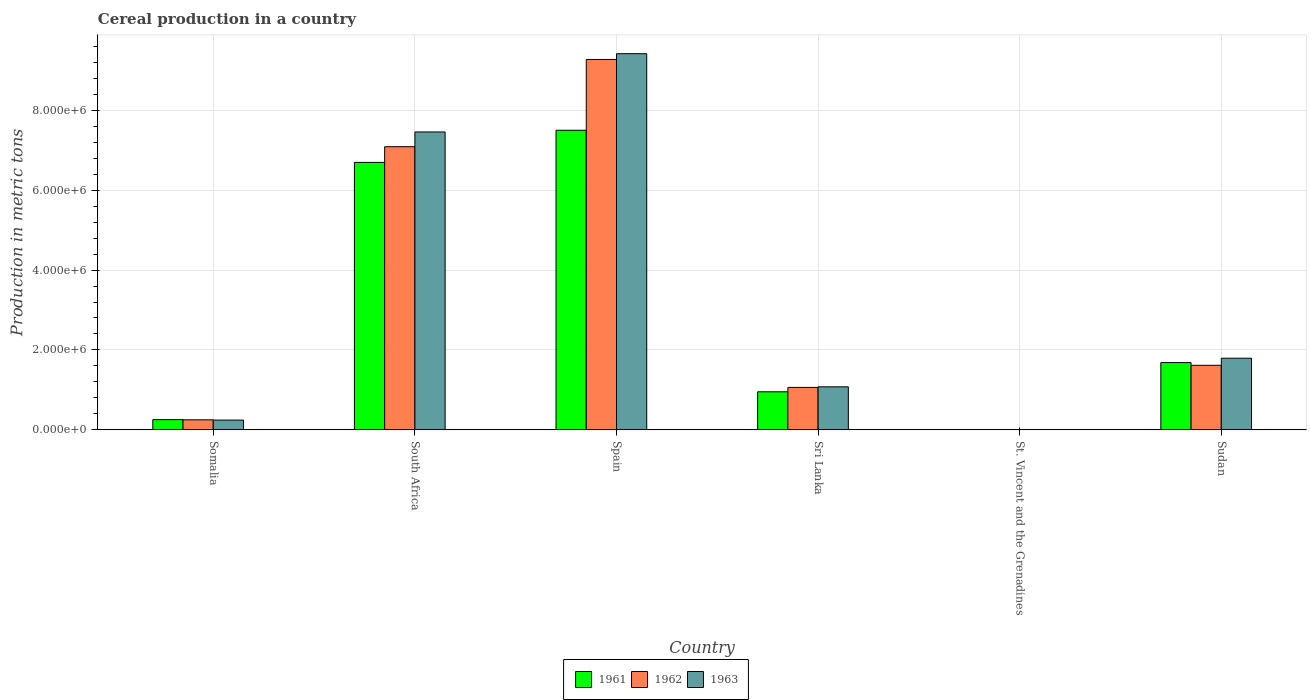How many different coloured bars are there?
Your answer should be very brief. 3. How many groups of bars are there?
Make the answer very short. 6. Are the number of bars per tick equal to the number of legend labels?
Provide a succinct answer. Yes. How many bars are there on the 1st tick from the left?
Your answer should be very brief. 3. What is the label of the 6th group of bars from the left?
Provide a short and direct response. Sudan. In how many cases, is the number of bars for a given country not equal to the number of legend labels?
Offer a terse response. 0. What is the total cereal production in 1961 in Spain?
Provide a short and direct response. 7.50e+06. Across all countries, what is the maximum total cereal production in 1963?
Provide a succinct answer. 9.42e+06. Across all countries, what is the minimum total cereal production in 1961?
Provide a short and direct response. 400. In which country was the total cereal production in 1963 minimum?
Offer a terse response. St. Vincent and the Grenadines. What is the total total cereal production in 1963 in the graph?
Give a very brief answer. 2.00e+07. What is the difference between the total cereal production in 1962 in Somalia and that in Spain?
Ensure brevity in your answer.  -9.02e+06. What is the difference between the total cereal production in 1961 in St. Vincent and the Grenadines and the total cereal production in 1963 in Sudan?
Keep it short and to the point. -1.79e+06. What is the average total cereal production in 1962 per country?
Make the answer very short. 3.22e+06. What is the difference between the total cereal production of/in 1961 and total cereal production of/in 1963 in Somalia?
Ensure brevity in your answer.  1.20e+04. What is the ratio of the total cereal production in 1963 in South Africa to that in Sudan?
Offer a terse response. 4.16. What is the difference between the highest and the second highest total cereal production in 1961?
Your response must be concise. 5.82e+06. What is the difference between the highest and the lowest total cereal production in 1961?
Give a very brief answer. 7.50e+06. In how many countries, is the total cereal production in 1961 greater than the average total cereal production in 1961 taken over all countries?
Offer a terse response. 2. What does the 1st bar from the left in St. Vincent and the Grenadines represents?
Offer a terse response. 1961. Is it the case that in every country, the sum of the total cereal production in 1962 and total cereal production in 1961 is greater than the total cereal production in 1963?
Offer a very short reply. Yes. Are the values on the major ticks of Y-axis written in scientific E-notation?
Your answer should be compact. Yes. Where does the legend appear in the graph?
Give a very brief answer. Bottom center. How many legend labels are there?
Provide a succinct answer. 3. What is the title of the graph?
Offer a very short reply. Cereal production in a country. Does "2002" appear as one of the legend labels in the graph?
Keep it short and to the point. No. What is the label or title of the X-axis?
Provide a succinct answer. Country. What is the label or title of the Y-axis?
Provide a succinct answer. Production in metric tons. What is the Production in metric tons in 1961 in Somalia?
Your response must be concise. 2.55e+05. What is the Production in metric tons of 1963 in Somalia?
Your response must be concise. 2.43e+05. What is the Production in metric tons in 1961 in South Africa?
Provide a succinct answer. 6.70e+06. What is the Production in metric tons of 1962 in South Africa?
Offer a very short reply. 7.09e+06. What is the Production in metric tons in 1963 in South Africa?
Give a very brief answer. 7.46e+06. What is the Production in metric tons of 1961 in Spain?
Provide a succinct answer. 7.50e+06. What is the Production in metric tons of 1962 in Spain?
Offer a terse response. 9.27e+06. What is the Production in metric tons in 1963 in Spain?
Your answer should be compact. 9.42e+06. What is the Production in metric tons in 1961 in Sri Lanka?
Keep it short and to the point. 9.52e+05. What is the Production in metric tons in 1962 in Sri Lanka?
Your answer should be compact. 1.06e+06. What is the Production in metric tons in 1963 in Sri Lanka?
Provide a short and direct response. 1.08e+06. What is the Production in metric tons of 1961 in Sudan?
Your answer should be compact. 1.68e+06. What is the Production in metric tons of 1962 in Sudan?
Your response must be concise. 1.62e+06. What is the Production in metric tons of 1963 in Sudan?
Provide a succinct answer. 1.79e+06. Across all countries, what is the maximum Production in metric tons in 1961?
Provide a short and direct response. 7.50e+06. Across all countries, what is the maximum Production in metric tons in 1962?
Your response must be concise. 9.27e+06. Across all countries, what is the maximum Production in metric tons in 1963?
Your answer should be very brief. 9.42e+06. Across all countries, what is the minimum Production in metric tons of 1962?
Offer a terse response. 400. What is the total Production in metric tons in 1961 in the graph?
Keep it short and to the point. 1.71e+07. What is the total Production in metric tons of 1962 in the graph?
Keep it short and to the point. 1.93e+07. What is the total Production in metric tons of 1963 in the graph?
Keep it short and to the point. 2.00e+07. What is the difference between the Production in metric tons in 1961 in Somalia and that in South Africa?
Your response must be concise. -6.44e+06. What is the difference between the Production in metric tons of 1962 in Somalia and that in South Africa?
Make the answer very short. -6.84e+06. What is the difference between the Production in metric tons in 1963 in Somalia and that in South Africa?
Make the answer very short. -7.22e+06. What is the difference between the Production in metric tons in 1961 in Somalia and that in Spain?
Your answer should be very brief. -7.25e+06. What is the difference between the Production in metric tons of 1962 in Somalia and that in Spain?
Your response must be concise. -9.02e+06. What is the difference between the Production in metric tons in 1963 in Somalia and that in Spain?
Provide a succinct answer. -9.18e+06. What is the difference between the Production in metric tons of 1961 in Somalia and that in Sri Lanka?
Make the answer very short. -6.97e+05. What is the difference between the Production in metric tons in 1962 in Somalia and that in Sri Lanka?
Give a very brief answer. -8.12e+05. What is the difference between the Production in metric tons of 1963 in Somalia and that in Sri Lanka?
Provide a short and direct response. -8.34e+05. What is the difference between the Production in metric tons of 1961 in Somalia and that in St. Vincent and the Grenadines?
Your answer should be compact. 2.55e+05. What is the difference between the Production in metric tons of 1962 in Somalia and that in St. Vincent and the Grenadines?
Give a very brief answer. 2.50e+05. What is the difference between the Production in metric tons in 1963 in Somalia and that in St. Vincent and the Grenadines?
Ensure brevity in your answer.  2.43e+05. What is the difference between the Production in metric tons of 1961 in Somalia and that in Sudan?
Offer a terse response. -1.43e+06. What is the difference between the Production in metric tons in 1962 in Somalia and that in Sudan?
Give a very brief answer. -1.37e+06. What is the difference between the Production in metric tons of 1963 in Somalia and that in Sudan?
Provide a succinct answer. -1.55e+06. What is the difference between the Production in metric tons in 1961 in South Africa and that in Spain?
Your response must be concise. -8.05e+05. What is the difference between the Production in metric tons of 1962 in South Africa and that in Spain?
Keep it short and to the point. -2.19e+06. What is the difference between the Production in metric tons of 1963 in South Africa and that in Spain?
Provide a short and direct response. -1.96e+06. What is the difference between the Production in metric tons in 1961 in South Africa and that in Sri Lanka?
Your answer should be very brief. 5.74e+06. What is the difference between the Production in metric tons in 1962 in South Africa and that in Sri Lanka?
Offer a very short reply. 6.03e+06. What is the difference between the Production in metric tons of 1963 in South Africa and that in Sri Lanka?
Your response must be concise. 6.38e+06. What is the difference between the Production in metric tons of 1961 in South Africa and that in St. Vincent and the Grenadines?
Offer a very short reply. 6.70e+06. What is the difference between the Production in metric tons of 1962 in South Africa and that in St. Vincent and the Grenadines?
Offer a terse response. 7.09e+06. What is the difference between the Production in metric tons of 1963 in South Africa and that in St. Vincent and the Grenadines?
Provide a short and direct response. 7.46e+06. What is the difference between the Production in metric tons in 1961 in South Africa and that in Sudan?
Ensure brevity in your answer.  5.01e+06. What is the difference between the Production in metric tons of 1962 in South Africa and that in Sudan?
Provide a succinct answer. 5.47e+06. What is the difference between the Production in metric tons of 1963 in South Africa and that in Sudan?
Provide a succinct answer. 5.67e+06. What is the difference between the Production in metric tons in 1961 in Spain and that in Sri Lanka?
Your answer should be very brief. 6.55e+06. What is the difference between the Production in metric tons in 1962 in Spain and that in Sri Lanka?
Make the answer very short. 8.21e+06. What is the difference between the Production in metric tons of 1963 in Spain and that in Sri Lanka?
Offer a terse response. 8.34e+06. What is the difference between the Production in metric tons in 1961 in Spain and that in St. Vincent and the Grenadines?
Give a very brief answer. 7.50e+06. What is the difference between the Production in metric tons in 1962 in Spain and that in St. Vincent and the Grenadines?
Ensure brevity in your answer.  9.27e+06. What is the difference between the Production in metric tons of 1963 in Spain and that in St. Vincent and the Grenadines?
Ensure brevity in your answer.  9.42e+06. What is the difference between the Production in metric tons of 1961 in Spain and that in Sudan?
Give a very brief answer. 5.82e+06. What is the difference between the Production in metric tons in 1962 in Spain and that in Sudan?
Your answer should be compact. 7.66e+06. What is the difference between the Production in metric tons of 1963 in Spain and that in Sudan?
Your answer should be very brief. 7.63e+06. What is the difference between the Production in metric tons of 1961 in Sri Lanka and that in St. Vincent and the Grenadines?
Your answer should be very brief. 9.51e+05. What is the difference between the Production in metric tons of 1962 in Sri Lanka and that in St. Vincent and the Grenadines?
Ensure brevity in your answer.  1.06e+06. What is the difference between the Production in metric tons of 1963 in Sri Lanka and that in St. Vincent and the Grenadines?
Provide a short and direct response. 1.08e+06. What is the difference between the Production in metric tons of 1961 in Sri Lanka and that in Sudan?
Provide a succinct answer. -7.31e+05. What is the difference between the Production in metric tons of 1962 in Sri Lanka and that in Sudan?
Ensure brevity in your answer.  -5.54e+05. What is the difference between the Production in metric tons of 1963 in Sri Lanka and that in Sudan?
Your answer should be compact. -7.16e+05. What is the difference between the Production in metric tons of 1961 in St. Vincent and the Grenadines and that in Sudan?
Give a very brief answer. -1.68e+06. What is the difference between the Production in metric tons in 1962 in St. Vincent and the Grenadines and that in Sudan?
Keep it short and to the point. -1.61e+06. What is the difference between the Production in metric tons in 1963 in St. Vincent and the Grenadines and that in Sudan?
Ensure brevity in your answer.  -1.79e+06. What is the difference between the Production in metric tons in 1961 in Somalia and the Production in metric tons in 1962 in South Africa?
Make the answer very short. -6.83e+06. What is the difference between the Production in metric tons in 1961 in Somalia and the Production in metric tons in 1963 in South Africa?
Your answer should be very brief. -7.20e+06. What is the difference between the Production in metric tons of 1962 in Somalia and the Production in metric tons of 1963 in South Africa?
Your response must be concise. -7.21e+06. What is the difference between the Production in metric tons of 1961 in Somalia and the Production in metric tons of 1962 in Spain?
Your answer should be very brief. -9.02e+06. What is the difference between the Production in metric tons in 1961 in Somalia and the Production in metric tons in 1963 in Spain?
Your answer should be very brief. -9.16e+06. What is the difference between the Production in metric tons in 1962 in Somalia and the Production in metric tons in 1963 in Spain?
Provide a succinct answer. -9.17e+06. What is the difference between the Production in metric tons in 1961 in Somalia and the Production in metric tons in 1962 in Sri Lanka?
Ensure brevity in your answer.  -8.07e+05. What is the difference between the Production in metric tons in 1961 in Somalia and the Production in metric tons in 1963 in Sri Lanka?
Your answer should be compact. -8.22e+05. What is the difference between the Production in metric tons of 1962 in Somalia and the Production in metric tons of 1963 in Sri Lanka?
Provide a succinct answer. -8.27e+05. What is the difference between the Production in metric tons in 1961 in Somalia and the Production in metric tons in 1962 in St. Vincent and the Grenadines?
Your response must be concise. 2.55e+05. What is the difference between the Production in metric tons in 1961 in Somalia and the Production in metric tons in 1963 in St. Vincent and the Grenadines?
Give a very brief answer. 2.55e+05. What is the difference between the Production in metric tons in 1962 in Somalia and the Production in metric tons in 1963 in St. Vincent and the Grenadines?
Offer a terse response. 2.50e+05. What is the difference between the Production in metric tons of 1961 in Somalia and the Production in metric tons of 1962 in Sudan?
Make the answer very short. -1.36e+06. What is the difference between the Production in metric tons of 1961 in Somalia and the Production in metric tons of 1963 in Sudan?
Make the answer very short. -1.54e+06. What is the difference between the Production in metric tons in 1962 in Somalia and the Production in metric tons in 1963 in Sudan?
Provide a short and direct response. -1.54e+06. What is the difference between the Production in metric tons in 1961 in South Africa and the Production in metric tons in 1962 in Spain?
Make the answer very short. -2.58e+06. What is the difference between the Production in metric tons in 1961 in South Africa and the Production in metric tons in 1963 in Spain?
Make the answer very short. -2.72e+06. What is the difference between the Production in metric tons in 1962 in South Africa and the Production in metric tons in 1963 in Spain?
Offer a terse response. -2.33e+06. What is the difference between the Production in metric tons of 1961 in South Africa and the Production in metric tons of 1962 in Sri Lanka?
Give a very brief answer. 5.63e+06. What is the difference between the Production in metric tons of 1961 in South Africa and the Production in metric tons of 1963 in Sri Lanka?
Offer a very short reply. 5.62e+06. What is the difference between the Production in metric tons of 1962 in South Africa and the Production in metric tons of 1963 in Sri Lanka?
Ensure brevity in your answer.  6.01e+06. What is the difference between the Production in metric tons of 1961 in South Africa and the Production in metric tons of 1962 in St. Vincent and the Grenadines?
Your answer should be very brief. 6.70e+06. What is the difference between the Production in metric tons of 1961 in South Africa and the Production in metric tons of 1963 in St. Vincent and the Grenadines?
Offer a very short reply. 6.70e+06. What is the difference between the Production in metric tons of 1962 in South Africa and the Production in metric tons of 1963 in St. Vincent and the Grenadines?
Your answer should be very brief. 7.09e+06. What is the difference between the Production in metric tons in 1961 in South Africa and the Production in metric tons in 1962 in Sudan?
Provide a succinct answer. 5.08e+06. What is the difference between the Production in metric tons in 1961 in South Africa and the Production in metric tons in 1963 in Sudan?
Provide a short and direct response. 4.90e+06. What is the difference between the Production in metric tons of 1962 in South Africa and the Production in metric tons of 1963 in Sudan?
Your answer should be compact. 5.30e+06. What is the difference between the Production in metric tons in 1961 in Spain and the Production in metric tons in 1962 in Sri Lanka?
Keep it short and to the point. 6.44e+06. What is the difference between the Production in metric tons of 1961 in Spain and the Production in metric tons of 1963 in Sri Lanka?
Ensure brevity in your answer.  6.42e+06. What is the difference between the Production in metric tons in 1962 in Spain and the Production in metric tons in 1963 in Sri Lanka?
Keep it short and to the point. 8.20e+06. What is the difference between the Production in metric tons in 1961 in Spain and the Production in metric tons in 1962 in St. Vincent and the Grenadines?
Give a very brief answer. 7.50e+06. What is the difference between the Production in metric tons of 1961 in Spain and the Production in metric tons of 1963 in St. Vincent and the Grenadines?
Provide a short and direct response. 7.50e+06. What is the difference between the Production in metric tons of 1962 in Spain and the Production in metric tons of 1963 in St. Vincent and the Grenadines?
Make the answer very short. 9.27e+06. What is the difference between the Production in metric tons of 1961 in Spain and the Production in metric tons of 1962 in Sudan?
Your answer should be very brief. 5.89e+06. What is the difference between the Production in metric tons of 1961 in Spain and the Production in metric tons of 1963 in Sudan?
Provide a succinct answer. 5.71e+06. What is the difference between the Production in metric tons of 1962 in Spain and the Production in metric tons of 1963 in Sudan?
Ensure brevity in your answer.  7.48e+06. What is the difference between the Production in metric tons of 1961 in Sri Lanka and the Production in metric tons of 1962 in St. Vincent and the Grenadines?
Make the answer very short. 9.51e+05. What is the difference between the Production in metric tons of 1961 in Sri Lanka and the Production in metric tons of 1963 in St. Vincent and the Grenadines?
Your response must be concise. 9.51e+05. What is the difference between the Production in metric tons in 1962 in Sri Lanka and the Production in metric tons in 1963 in St. Vincent and the Grenadines?
Provide a succinct answer. 1.06e+06. What is the difference between the Production in metric tons in 1961 in Sri Lanka and the Production in metric tons in 1962 in Sudan?
Your response must be concise. -6.63e+05. What is the difference between the Production in metric tons in 1961 in Sri Lanka and the Production in metric tons in 1963 in Sudan?
Provide a succinct answer. -8.41e+05. What is the difference between the Production in metric tons in 1962 in Sri Lanka and the Production in metric tons in 1963 in Sudan?
Offer a terse response. -7.31e+05. What is the difference between the Production in metric tons of 1961 in St. Vincent and the Grenadines and the Production in metric tons of 1962 in Sudan?
Make the answer very short. -1.61e+06. What is the difference between the Production in metric tons of 1961 in St. Vincent and the Grenadines and the Production in metric tons of 1963 in Sudan?
Keep it short and to the point. -1.79e+06. What is the difference between the Production in metric tons in 1962 in St. Vincent and the Grenadines and the Production in metric tons in 1963 in Sudan?
Offer a very short reply. -1.79e+06. What is the average Production in metric tons of 1961 per country?
Give a very brief answer. 2.85e+06. What is the average Production in metric tons of 1962 per country?
Give a very brief answer. 3.22e+06. What is the average Production in metric tons in 1963 per country?
Provide a succinct answer. 3.33e+06. What is the difference between the Production in metric tons in 1961 and Production in metric tons in 1963 in Somalia?
Give a very brief answer. 1.20e+04. What is the difference between the Production in metric tons of 1962 and Production in metric tons of 1963 in Somalia?
Provide a short and direct response. 7000. What is the difference between the Production in metric tons in 1961 and Production in metric tons in 1962 in South Africa?
Offer a very short reply. -3.93e+05. What is the difference between the Production in metric tons in 1961 and Production in metric tons in 1963 in South Africa?
Make the answer very short. -7.62e+05. What is the difference between the Production in metric tons of 1962 and Production in metric tons of 1963 in South Africa?
Make the answer very short. -3.69e+05. What is the difference between the Production in metric tons in 1961 and Production in metric tons in 1962 in Spain?
Your answer should be compact. -1.77e+06. What is the difference between the Production in metric tons of 1961 and Production in metric tons of 1963 in Spain?
Give a very brief answer. -1.92e+06. What is the difference between the Production in metric tons of 1962 and Production in metric tons of 1963 in Spain?
Ensure brevity in your answer.  -1.45e+05. What is the difference between the Production in metric tons of 1961 and Production in metric tons of 1962 in Sri Lanka?
Your answer should be compact. -1.10e+05. What is the difference between the Production in metric tons of 1961 and Production in metric tons of 1963 in Sri Lanka?
Keep it short and to the point. -1.25e+05. What is the difference between the Production in metric tons of 1962 and Production in metric tons of 1963 in Sri Lanka?
Offer a terse response. -1.48e+04. What is the difference between the Production in metric tons in 1961 and Production in metric tons in 1962 in St. Vincent and the Grenadines?
Make the answer very short. 0. What is the difference between the Production in metric tons of 1961 and Production in metric tons of 1963 in St. Vincent and the Grenadines?
Your answer should be very brief. 0. What is the difference between the Production in metric tons of 1962 and Production in metric tons of 1963 in St. Vincent and the Grenadines?
Ensure brevity in your answer.  0. What is the difference between the Production in metric tons of 1961 and Production in metric tons of 1962 in Sudan?
Offer a very short reply. 6.75e+04. What is the difference between the Production in metric tons of 1961 and Production in metric tons of 1963 in Sudan?
Your answer should be compact. -1.10e+05. What is the difference between the Production in metric tons of 1962 and Production in metric tons of 1963 in Sudan?
Ensure brevity in your answer.  -1.77e+05. What is the ratio of the Production in metric tons in 1961 in Somalia to that in South Africa?
Offer a very short reply. 0.04. What is the ratio of the Production in metric tons of 1962 in Somalia to that in South Africa?
Offer a very short reply. 0.04. What is the ratio of the Production in metric tons in 1963 in Somalia to that in South Africa?
Provide a succinct answer. 0.03. What is the ratio of the Production in metric tons of 1961 in Somalia to that in Spain?
Provide a short and direct response. 0.03. What is the ratio of the Production in metric tons in 1962 in Somalia to that in Spain?
Ensure brevity in your answer.  0.03. What is the ratio of the Production in metric tons of 1963 in Somalia to that in Spain?
Ensure brevity in your answer.  0.03. What is the ratio of the Production in metric tons in 1961 in Somalia to that in Sri Lanka?
Offer a terse response. 0.27. What is the ratio of the Production in metric tons of 1962 in Somalia to that in Sri Lanka?
Provide a short and direct response. 0.24. What is the ratio of the Production in metric tons of 1963 in Somalia to that in Sri Lanka?
Provide a short and direct response. 0.23. What is the ratio of the Production in metric tons in 1961 in Somalia to that in St. Vincent and the Grenadines?
Keep it short and to the point. 637.5. What is the ratio of the Production in metric tons of 1962 in Somalia to that in St. Vincent and the Grenadines?
Offer a terse response. 625. What is the ratio of the Production in metric tons in 1963 in Somalia to that in St. Vincent and the Grenadines?
Give a very brief answer. 607.5. What is the ratio of the Production in metric tons of 1961 in Somalia to that in Sudan?
Make the answer very short. 0.15. What is the ratio of the Production in metric tons in 1962 in Somalia to that in Sudan?
Ensure brevity in your answer.  0.15. What is the ratio of the Production in metric tons of 1963 in Somalia to that in Sudan?
Your answer should be very brief. 0.14. What is the ratio of the Production in metric tons of 1961 in South Africa to that in Spain?
Make the answer very short. 0.89. What is the ratio of the Production in metric tons in 1962 in South Africa to that in Spain?
Your answer should be compact. 0.76. What is the ratio of the Production in metric tons in 1963 in South Africa to that in Spain?
Your answer should be compact. 0.79. What is the ratio of the Production in metric tons in 1961 in South Africa to that in Sri Lanka?
Your answer should be very brief. 7.04. What is the ratio of the Production in metric tons of 1962 in South Africa to that in Sri Lanka?
Offer a very short reply. 6.68. What is the ratio of the Production in metric tons of 1963 in South Africa to that in Sri Lanka?
Your response must be concise. 6.93. What is the ratio of the Production in metric tons in 1961 in South Africa to that in St. Vincent and the Grenadines?
Provide a short and direct response. 1.67e+04. What is the ratio of the Production in metric tons in 1962 in South Africa to that in St. Vincent and the Grenadines?
Provide a short and direct response. 1.77e+04. What is the ratio of the Production in metric tons of 1963 in South Africa to that in St. Vincent and the Grenadines?
Provide a succinct answer. 1.86e+04. What is the ratio of the Production in metric tons of 1961 in South Africa to that in Sudan?
Offer a terse response. 3.98. What is the ratio of the Production in metric tons of 1962 in South Africa to that in Sudan?
Ensure brevity in your answer.  4.39. What is the ratio of the Production in metric tons of 1963 in South Africa to that in Sudan?
Offer a terse response. 4.16. What is the ratio of the Production in metric tons of 1961 in Spain to that in Sri Lanka?
Make the answer very short. 7.88. What is the ratio of the Production in metric tons of 1962 in Spain to that in Sri Lanka?
Your response must be concise. 8.73. What is the ratio of the Production in metric tons of 1963 in Spain to that in Sri Lanka?
Ensure brevity in your answer.  8.75. What is the ratio of the Production in metric tons in 1961 in Spain to that in St. Vincent and the Grenadines?
Give a very brief answer. 1.88e+04. What is the ratio of the Production in metric tons of 1962 in Spain to that in St. Vincent and the Grenadines?
Offer a terse response. 2.32e+04. What is the ratio of the Production in metric tons in 1963 in Spain to that in St. Vincent and the Grenadines?
Give a very brief answer. 2.35e+04. What is the ratio of the Production in metric tons in 1961 in Spain to that in Sudan?
Your answer should be compact. 4.46. What is the ratio of the Production in metric tons in 1962 in Spain to that in Sudan?
Make the answer very short. 5.74. What is the ratio of the Production in metric tons of 1963 in Spain to that in Sudan?
Ensure brevity in your answer.  5.25. What is the ratio of the Production in metric tons in 1961 in Sri Lanka to that in St. Vincent and the Grenadines?
Offer a very short reply. 2379.67. What is the ratio of the Production in metric tons in 1962 in Sri Lanka to that in St. Vincent and the Grenadines?
Ensure brevity in your answer.  2654.57. What is the ratio of the Production in metric tons of 1963 in Sri Lanka to that in St. Vincent and the Grenadines?
Your answer should be compact. 2691.58. What is the ratio of the Production in metric tons in 1961 in Sri Lanka to that in Sudan?
Offer a terse response. 0.57. What is the ratio of the Production in metric tons of 1962 in Sri Lanka to that in Sudan?
Ensure brevity in your answer.  0.66. What is the ratio of the Production in metric tons in 1963 in Sri Lanka to that in Sudan?
Keep it short and to the point. 0.6. What is the difference between the highest and the second highest Production in metric tons in 1961?
Your answer should be very brief. 8.05e+05. What is the difference between the highest and the second highest Production in metric tons of 1962?
Ensure brevity in your answer.  2.19e+06. What is the difference between the highest and the second highest Production in metric tons in 1963?
Offer a very short reply. 1.96e+06. What is the difference between the highest and the lowest Production in metric tons of 1961?
Keep it short and to the point. 7.50e+06. What is the difference between the highest and the lowest Production in metric tons of 1962?
Your answer should be compact. 9.27e+06. What is the difference between the highest and the lowest Production in metric tons in 1963?
Keep it short and to the point. 9.42e+06. 